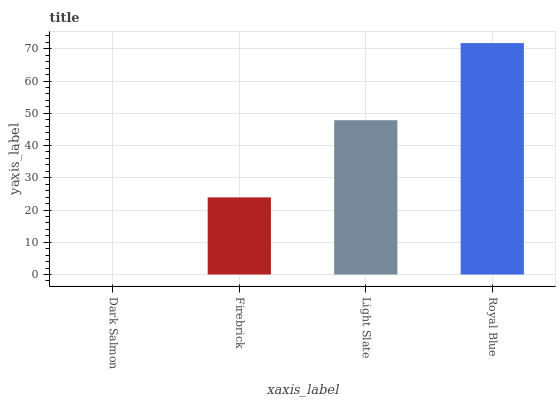Is Dark Salmon the minimum?
Answer yes or no. Yes. Is Royal Blue the maximum?
Answer yes or no. Yes. Is Firebrick the minimum?
Answer yes or no. No. Is Firebrick the maximum?
Answer yes or no. No. Is Firebrick greater than Dark Salmon?
Answer yes or no. Yes. Is Dark Salmon less than Firebrick?
Answer yes or no. Yes. Is Dark Salmon greater than Firebrick?
Answer yes or no. No. Is Firebrick less than Dark Salmon?
Answer yes or no. No. Is Light Slate the high median?
Answer yes or no. Yes. Is Firebrick the low median?
Answer yes or no. Yes. Is Royal Blue the high median?
Answer yes or no. No. Is Light Slate the low median?
Answer yes or no. No. 